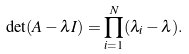Convert formula to latex. <formula><loc_0><loc_0><loc_500><loc_500>\det ( A - \lambda I ) = \prod _ { i = 1 } ^ { N } ( \lambda _ { i } - \lambda ) .</formula> 